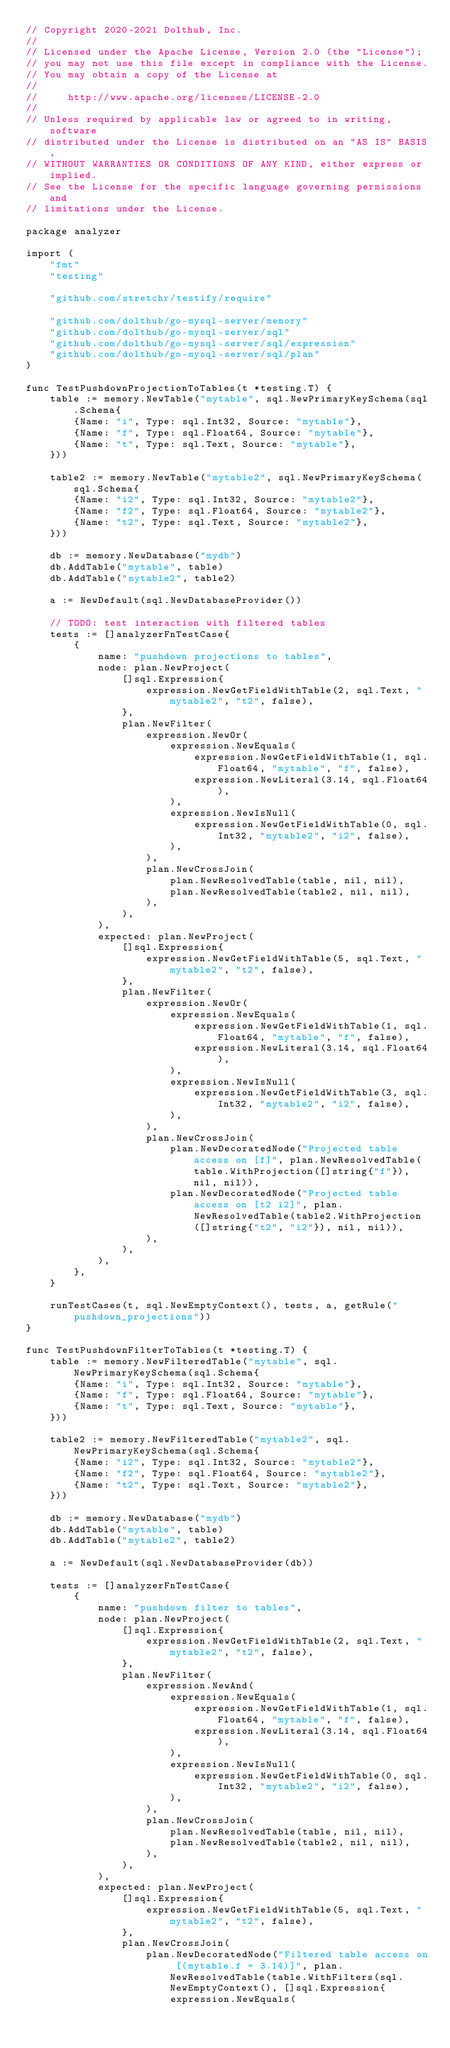Convert code to text. <code><loc_0><loc_0><loc_500><loc_500><_Go_>// Copyright 2020-2021 Dolthub, Inc.
//
// Licensed under the Apache License, Version 2.0 (the "License");
// you may not use this file except in compliance with the License.
// You may obtain a copy of the License at
//
//     http://www.apache.org/licenses/LICENSE-2.0
//
// Unless required by applicable law or agreed to in writing, software
// distributed under the License is distributed on an "AS IS" BASIS,
// WITHOUT WARRANTIES OR CONDITIONS OF ANY KIND, either express or implied.
// See the License for the specific language governing permissions and
// limitations under the License.

package analyzer

import (
	"fmt"
	"testing"

	"github.com/stretchr/testify/require"

	"github.com/dolthub/go-mysql-server/memory"
	"github.com/dolthub/go-mysql-server/sql"
	"github.com/dolthub/go-mysql-server/sql/expression"
	"github.com/dolthub/go-mysql-server/sql/plan"
)

func TestPushdownProjectionToTables(t *testing.T) {
	table := memory.NewTable("mytable", sql.NewPrimaryKeySchema(sql.Schema{
		{Name: "i", Type: sql.Int32, Source: "mytable"},
		{Name: "f", Type: sql.Float64, Source: "mytable"},
		{Name: "t", Type: sql.Text, Source: "mytable"},
	}))

	table2 := memory.NewTable("mytable2", sql.NewPrimaryKeySchema(sql.Schema{
		{Name: "i2", Type: sql.Int32, Source: "mytable2"},
		{Name: "f2", Type: sql.Float64, Source: "mytable2"},
		{Name: "t2", Type: sql.Text, Source: "mytable2"},
	}))

	db := memory.NewDatabase("mydb")
	db.AddTable("mytable", table)
	db.AddTable("mytable2", table2)

	a := NewDefault(sql.NewDatabaseProvider())

	// TODO: test interaction with filtered tables
	tests := []analyzerFnTestCase{
		{
			name: "pushdown projections to tables",
			node: plan.NewProject(
				[]sql.Expression{
					expression.NewGetFieldWithTable(2, sql.Text, "mytable2", "t2", false),
				},
				plan.NewFilter(
					expression.NewOr(
						expression.NewEquals(
							expression.NewGetFieldWithTable(1, sql.Float64, "mytable", "f", false),
							expression.NewLiteral(3.14, sql.Float64),
						),
						expression.NewIsNull(
							expression.NewGetFieldWithTable(0, sql.Int32, "mytable2", "i2", false),
						),
					),
					plan.NewCrossJoin(
						plan.NewResolvedTable(table, nil, nil),
						plan.NewResolvedTable(table2, nil, nil),
					),
				),
			),
			expected: plan.NewProject(
				[]sql.Expression{
					expression.NewGetFieldWithTable(5, sql.Text, "mytable2", "t2", false),
				},
				plan.NewFilter(
					expression.NewOr(
						expression.NewEquals(
							expression.NewGetFieldWithTable(1, sql.Float64, "mytable", "f", false),
							expression.NewLiteral(3.14, sql.Float64),
						),
						expression.NewIsNull(
							expression.NewGetFieldWithTable(3, sql.Int32, "mytable2", "i2", false),
						),
					),
					plan.NewCrossJoin(
						plan.NewDecoratedNode("Projected table access on [f]", plan.NewResolvedTable(table.WithProjection([]string{"f"}), nil, nil)),
						plan.NewDecoratedNode("Projected table access on [t2 i2]", plan.NewResolvedTable(table2.WithProjection([]string{"t2", "i2"}), nil, nil)),
					),
				),
			),
		},
	}

	runTestCases(t, sql.NewEmptyContext(), tests, a, getRule("pushdown_projections"))
}

func TestPushdownFilterToTables(t *testing.T) {
	table := memory.NewFilteredTable("mytable", sql.NewPrimaryKeySchema(sql.Schema{
		{Name: "i", Type: sql.Int32, Source: "mytable"},
		{Name: "f", Type: sql.Float64, Source: "mytable"},
		{Name: "t", Type: sql.Text, Source: "mytable"},
	}))

	table2 := memory.NewFilteredTable("mytable2", sql.NewPrimaryKeySchema(sql.Schema{
		{Name: "i2", Type: sql.Int32, Source: "mytable2"},
		{Name: "f2", Type: sql.Float64, Source: "mytable2"},
		{Name: "t2", Type: sql.Text, Source: "mytable2"},
	}))

	db := memory.NewDatabase("mydb")
	db.AddTable("mytable", table)
	db.AddTable("mytable2", table2)

	a := NewDefault(sql.NewDatabaseProvider(db))

	tests := []analyzerFnTestCase{
		{
			name: "pushdown filter to tables",
			node: plan.NewProject(
				[]sql.Expression{
					expression.NewGetFieldWithTable(2, sql.Text, "mytable2", "t2", false),
				},
				plan.NewFilter(
					expression.NewAnd(
						expression.NewEquals(
							expression.NewGetFieldWithTable(1, sql.Float64, "mytable", "f", false),
							expression.NewLiteral(3.14, sql.Float64),
						),
						expression.NewIsNull(
							expression.NewGetFieldWithTable(0, sql.Int32, "mytable2", "i2", false),
						),
					),
					plan.NewCrossJoin(
						plan.NewResolvedTable(table, nil, nil),
						plan.NewResolvedTable(table2, nil, nil),
					),
				),
			),
			expected: plan.NewProject(
				[]sql.Expression{
					expression.NewGetFieldWithTable(5, sql.Text, "mytable2", "t2", false),
				},
				plan.NewCrossJoin(
					plan.NewDecoratedNode("Filtered table access on [(mytable.f = 3.14)]", plan.NewResolvedTable(table.WithFilters(sql.NewEmptyContext(), []sql.Expression{
						expression.NewEquals(</code> 